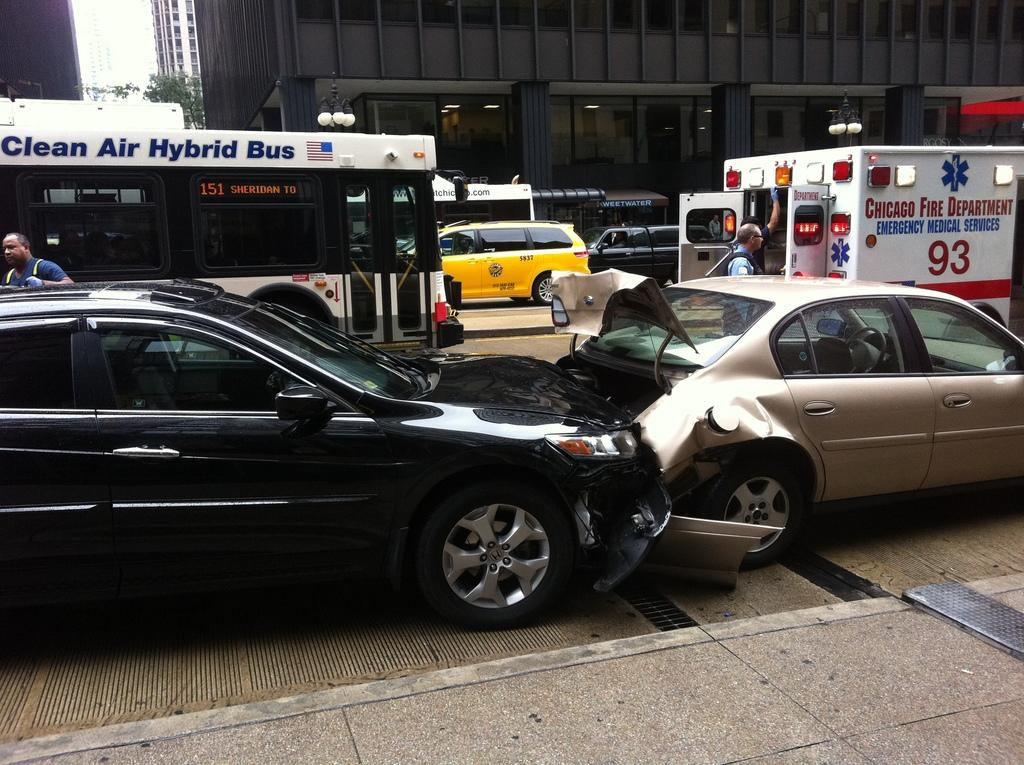Provide a one-sentence caption for the provided image. At the scene of a car accident is an ambulance and a clean air hybrid bus. 